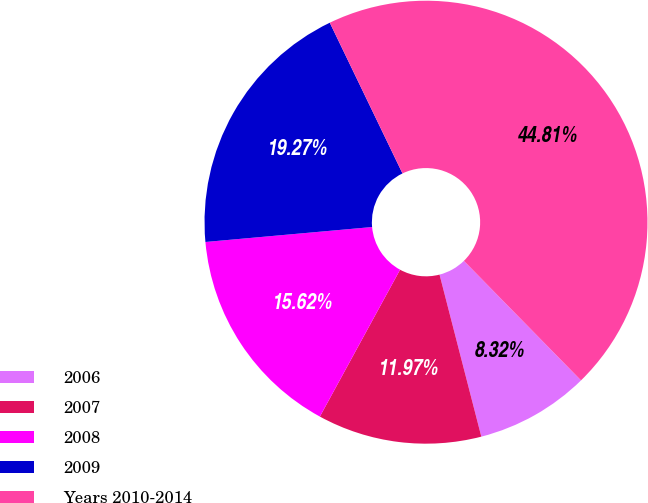<chart> <loc_0><loc_0><loc_500><loc_500><pie_chart><fcel>2006<fcel>2007<fcel>2008<fcel>2009<fcel>Years 2010-2014<nl><fcel>8.32%<fcel>11.97%<fcel>15.62%<fcel>19.27%<fcel>44.81%<nl></chart> 